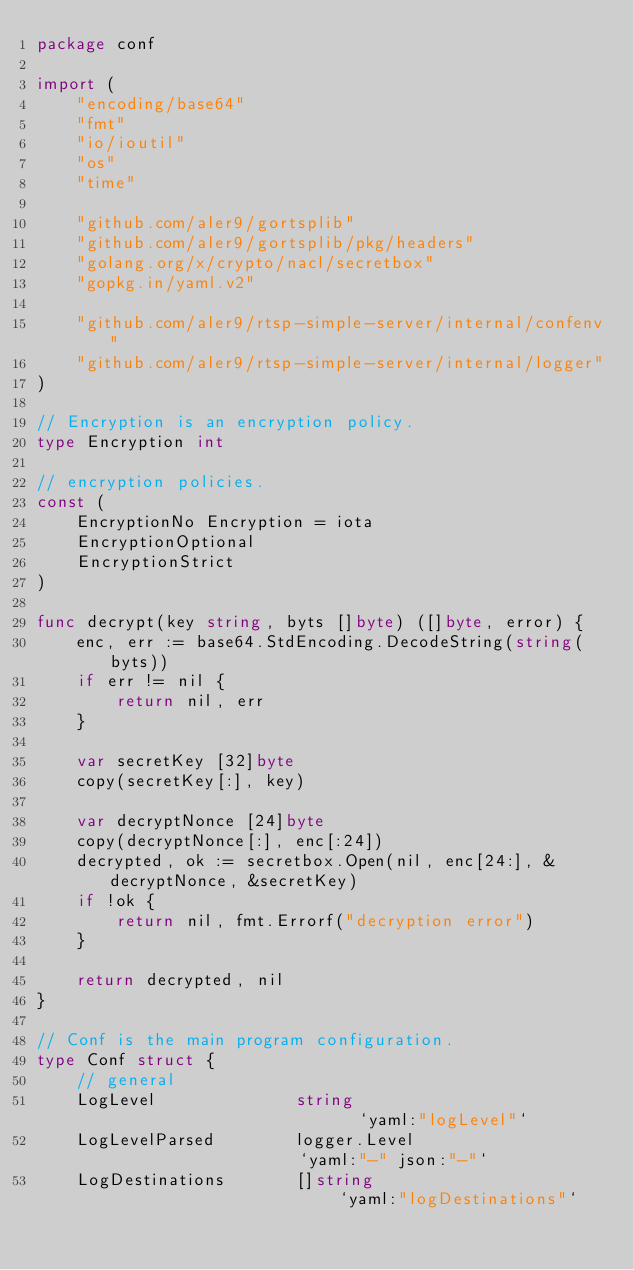<code> <loc_0><loc_0><loc_500><loc_500><_Go_>package conf

import (
	"encoding/base64"
	"fmt"
	"io/ioutil"
	"os"
	"time"

	"github.com/aler9/gortsplib"
	"github.com/aler9/gortsplib/pkg/headers"
	"golang.org/x/crypto/nacl/secretbox"
	"gopkg.in/yaml.v2"

	"github.com/aler9/rtsp-simple-server/internal/confenv"
	"github.com/aler9/rtsp-simple-server/internal/logger"
)

// Encryption is an encryption policy.
type Encryption int

// encryption policies.
const (
	EncryptionNo Encryption = iota
	EncryptionOptional
	EncryptionStrict
)

func decrypt(key string, byts []byte) ([]byte, error) {
	enc, err := base64.StdEncoding.DecodeString(string(byts))
	if err != nil {
		return nil, err
	}

	var secretKey [32]byte
	copy(secretKey[:], key)

	var decryptNonce [24]byte
	copy(decryptNonce[:], enc[:24])
	decrypted, ok := secretbox.Open(nil, enc[24:], &decryptNonce, &secretKey)
	if !ok {
		return nil, fmt.Errorf("decryption error")
	}

	return decrypted, nil
}

// Conf is the main program configuration.
type Conf struct {
	// general
	LogLevel              string                          `yaml:"logLevel"`
	LogLevelParsed        logger.Level                    `yaml:"-" json:"-"`
	LogDestinations       []string                        `yaml:"logDestinations"`</code> 